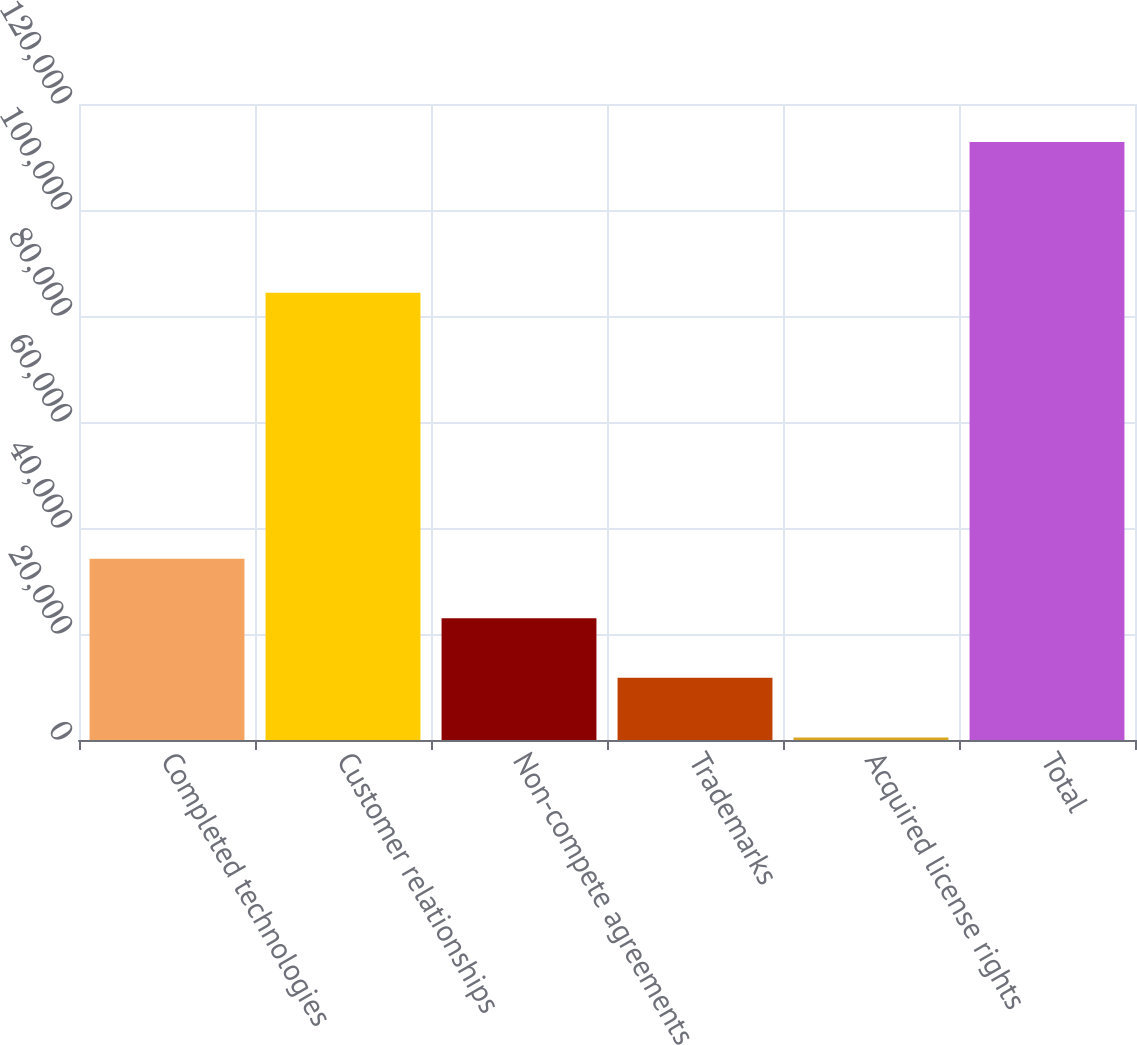Convert chart to OTSL. <chart><loc_0><loc_0><loc_500><loc_500><bar_chart><fcel>Completed technologies<fcel>Customer relationships<fcel>Non-compete agreements<fcel>Trademarks<fcel>Acquired license rights<fcel>Total<nl><fcel>34189.3<fcel>84400<fcel>22956.2<fcel>11723.1<fcel>490<fcel>112821<nl></chart> 